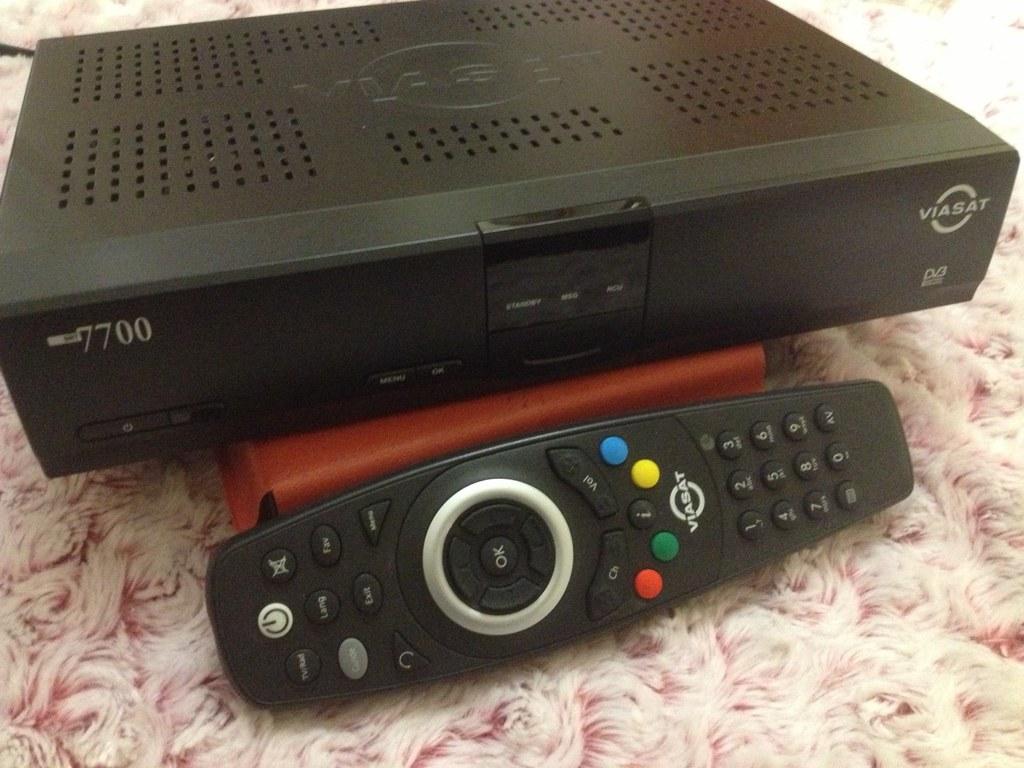What does the button on the center of the remote say?
Your answer should be compact. Ok. What is the name of the machine?
Keep it short and to the point. Viasat. 